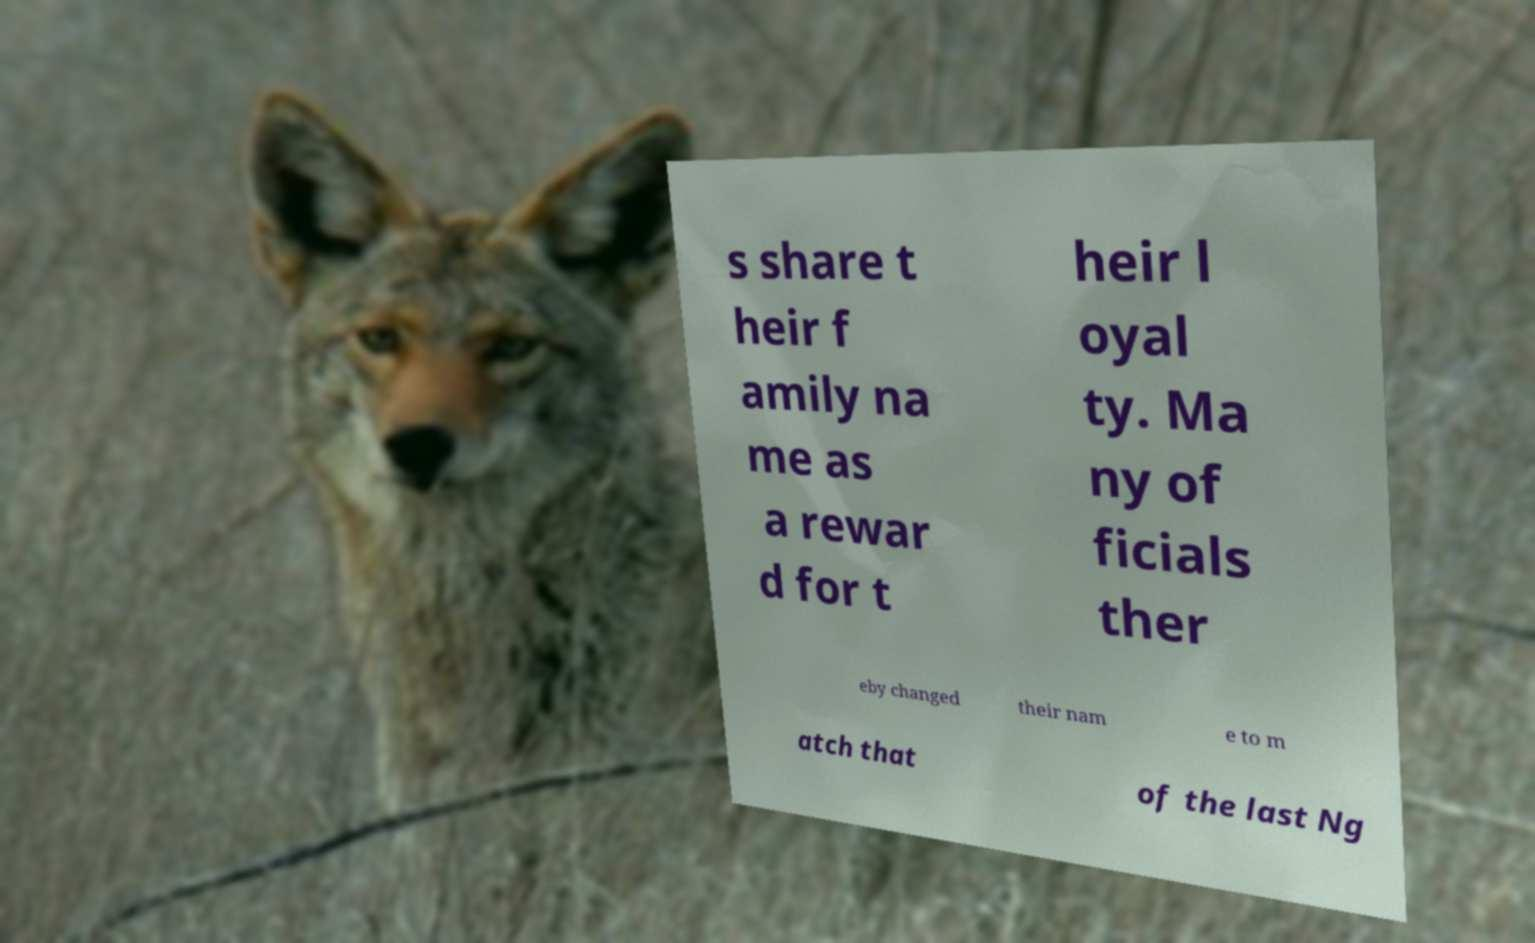Can you accurately transcribe the text from the provided image for me? s share t heir f amily na me as a rewar d for t heir l oyal ty. Ma ny of ficials ther eby changed their nam e to m atch that of the last Ng 